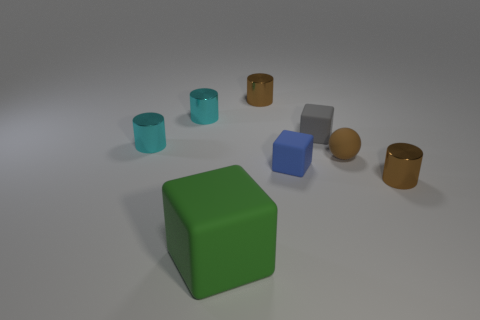Can you describe the objects in the center of the image? Certainly! In the center of the image, there is a large green cube. It has a matte surface and takes the spotlight, being the largest single object and quite prominent due to its rich color and central placement. 